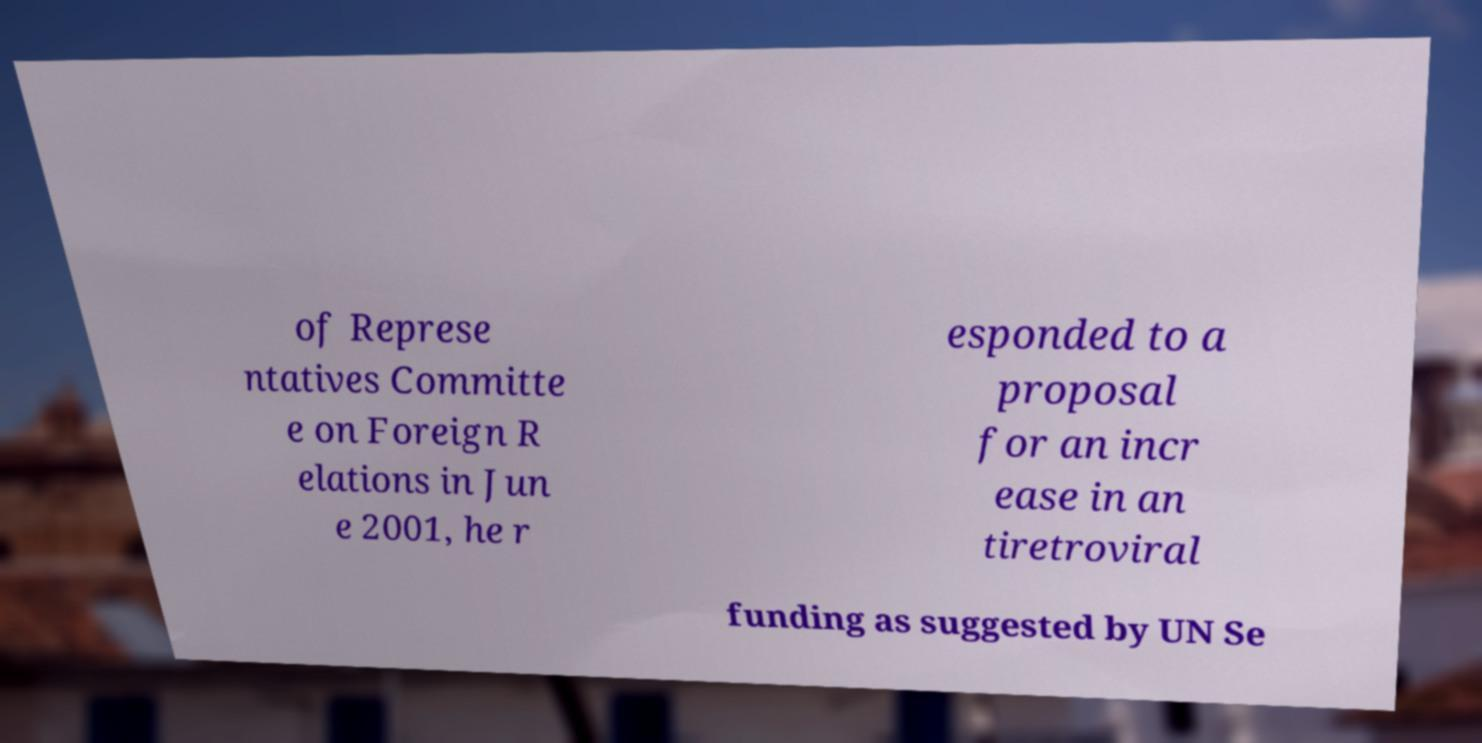Could you assist in decoding the text presented in this image and type it out clearly? of Represe ntatives Committe e on Foreign R elations in Jun e 2001, he r esponded to a proposal for an incr ease in an tiretroviral funding as suggested by UN Se 